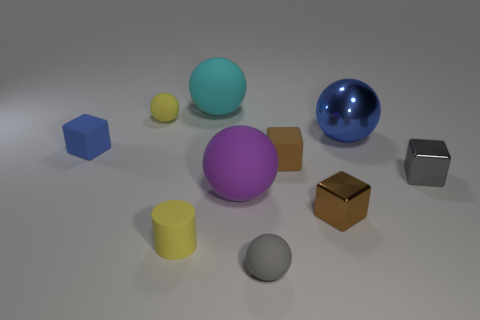There is a matte cylinder; is it the same color as the rubber sphere to the left of the tiny yellow cylinder?
Your answer should be compact. Yes. Is the number of big purple balls right of the blue metallic ball less than the number of large brown rubber cubes?
Give a very brief answer. No. What number of small blue rubber spheres are there?
Offer a terse response. 0. The gray object that is in front of the metal block that is in front of the purple rubber object is what shape?
Your answer should be very brief. Sphere. What number of brown objects are left of the blue ball?
Provide a short and direct response. 2. Does the cyan ball have the same material as the gray object that is on the right side of the gray matte sphere?
Your answer should be compact. No. Are there any yellow cylinders of the same size as the brown rubber cube?
Make the answer very short. Yes. Is the number of brown rubber blocks that are on the right side of the blue ball the same as the number of purple balls?
Ensure brevity in your answer.  No. The yellow rubber sphere has what size?
Ensure brevity in your answer.  Small. How many tiny gray matte balls are on the left side of the yellow rubber thing behind the small blue object?
Keep it short and to the point. 0. 